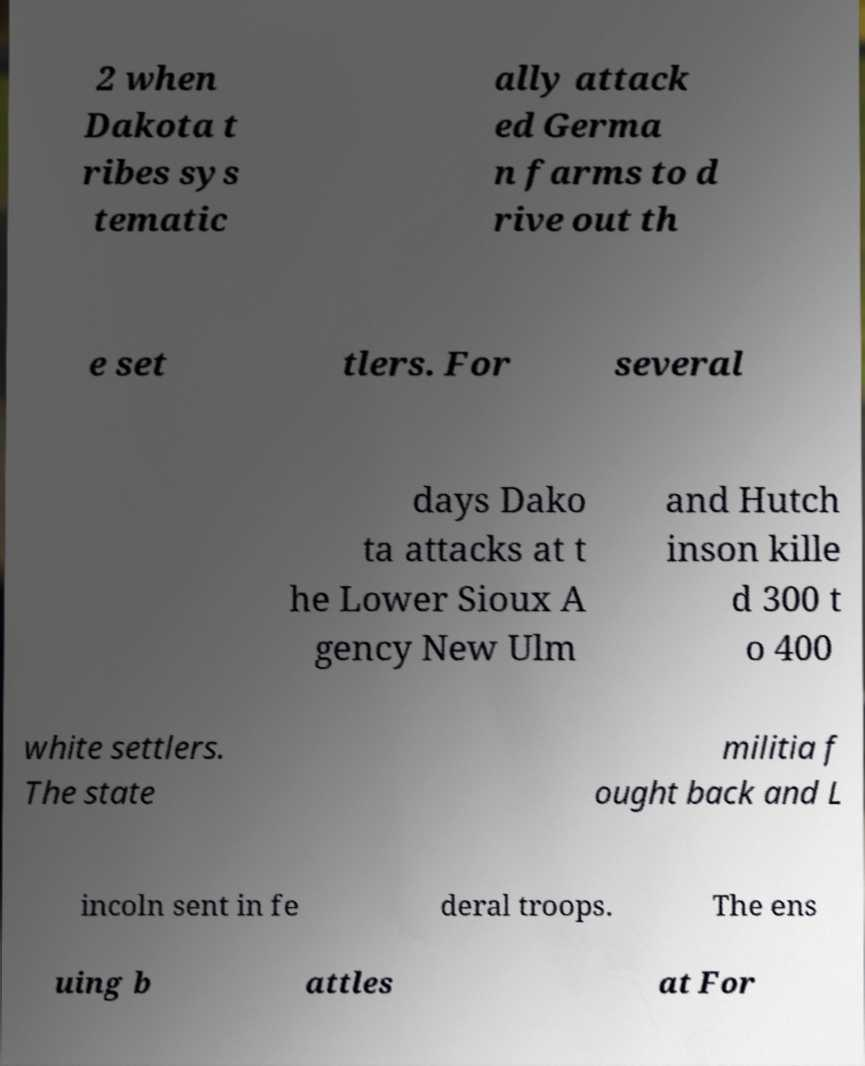There's text embedded in this image that I need extracted. Can you transcribe it verbatim? 2 when Dakota t ribes sys tematic ally attack ed Germa n farms to d rive out th e set tlers. For several days Dako ta attacks at t he Lower Sioux A gency New Ulm and Hutch inson kille d 300 t o 400 white settlers. The state militia f ought back and L incoln sent in fe deral troops. The ens uing b attles at For 